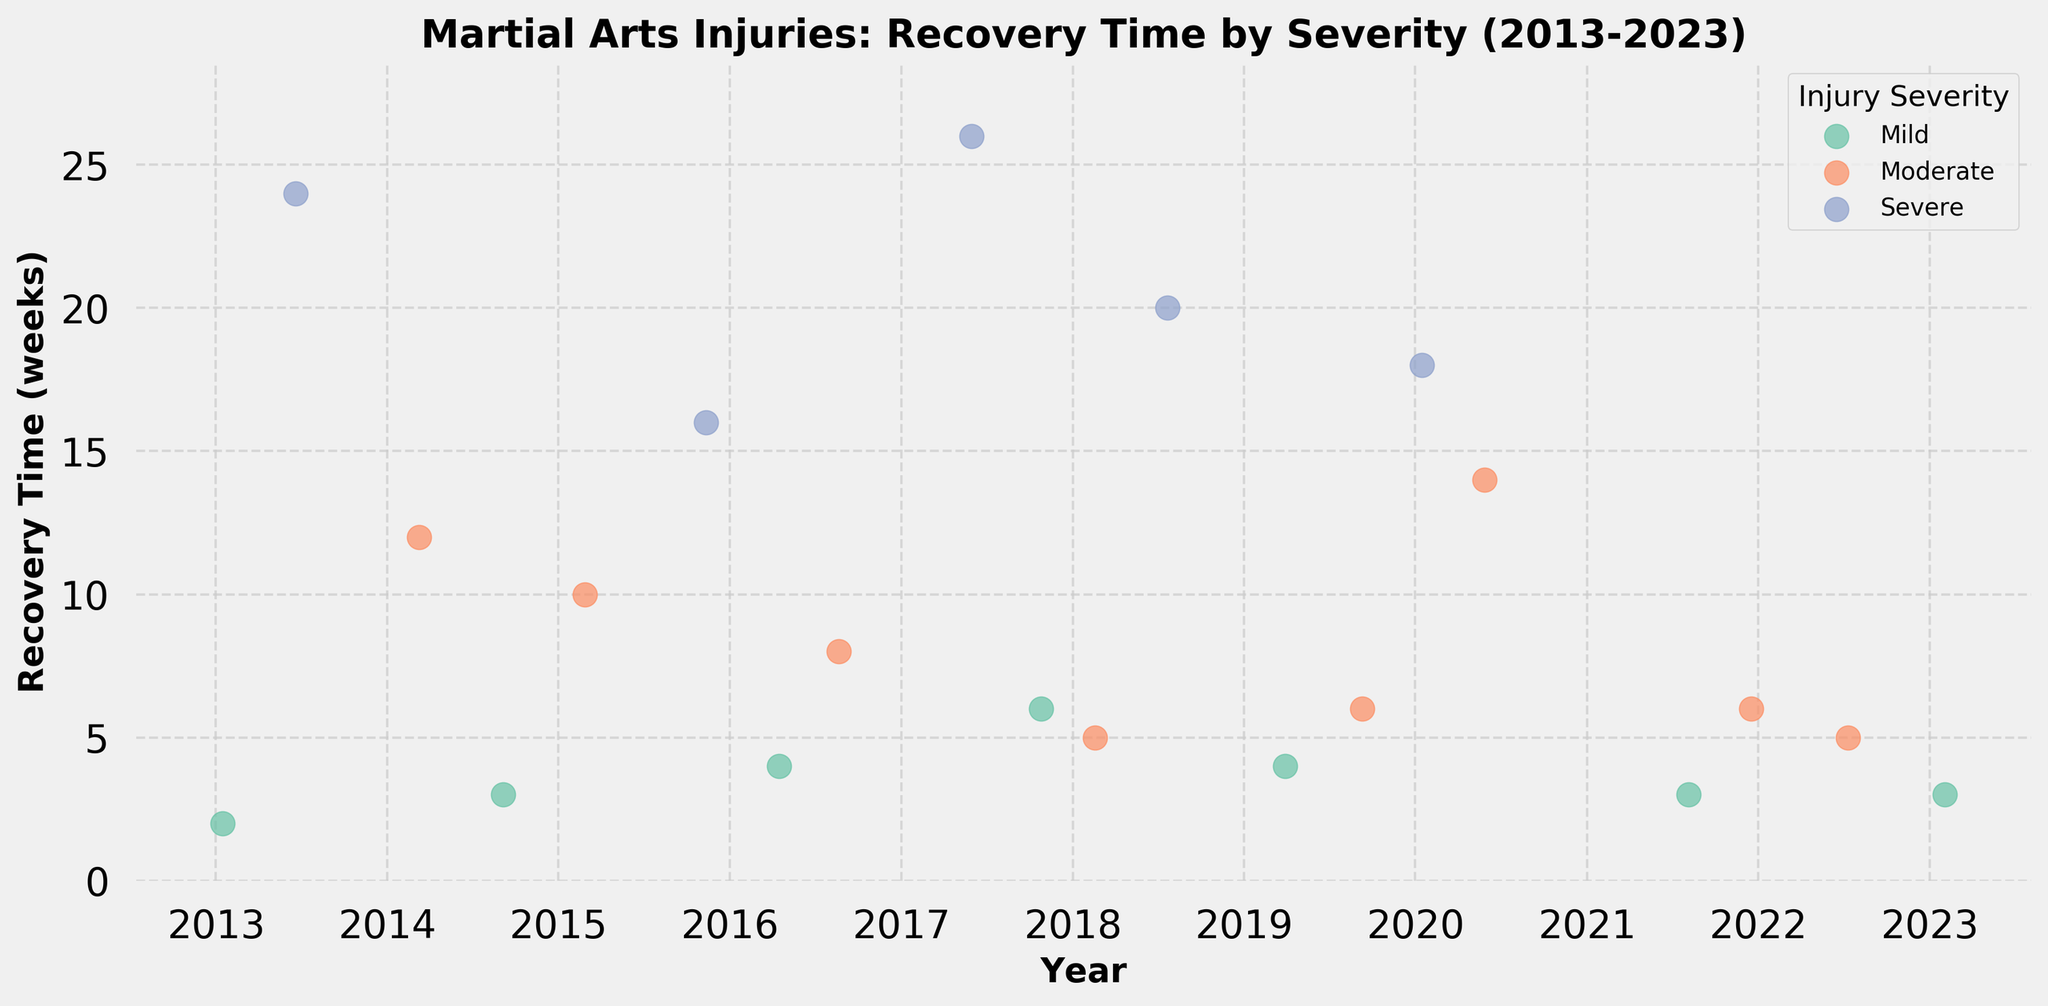What's the title of the figure? The title of a figure is usually displayed prominently at the top. In this case, it clearly states "Martial Arts Injuries: Recovery Time by Severity (2013-2023)".
Answer: Martial Arts Injuries: Recovery Time by Severity (2013-2023) What is the longest recovery time among severe injuries? To find this, look at the dots labeled "Severe" and identify the highest "Recovery Time (weeks)" along the y-axis. The highest point for severe injuries is 26 weeks.
Answer: 26 weeks How many severe injuries are shown in the figure? Count the number of dots represented by the color assigned to "Severe" injuries in the legend. There are four such dots.
Answer: Four Which year had the most injuries? To determine the year with the most injuries, observe the distribution of dots across different years on the x-axis. The year 2015 has the highest concentration of dots.
Answer: 2015 What's the range of recovery times for mild injuries? Look at the dots labeled "Mild" and note the minimum and maximum "Recovery Time (weeks)" values on the y-axis. The range is from 2 to 6 weeks.
Answer: 2 to 6 weeks Which type of injury occurred in February 2019 and how severe was it? By observing the x-axis and finding the dot in February 2019, and referring to the color and legend, we identify the injury "Elbow Hyperextension" with "Mild" severity.
Answer: Elbow Hyperextension, Mild Which injury had a recovery time of 14 weeks and in what year did it happen? Locate the dot at 14 weeks on the y-axis and trace back to its corresponding year on the x-axis. The "Dislocated Knee" had a recovery time of 14 weeks in 2020.
Answer: Dislocated Knee, 2020 Compare the median recovery times of moderate and severe injuries. Which is higher? First, find all recovery times for both moderate and severe injuries. Moderate: 12, 10, 8, 5, 6, 14, 5, 6 (Median = 8). Severe: 24, 16, 26, 20, 18 (Median = 20). The median recovery time for severe injuries is higher.
Answer: Severe (20 weeks) Between 2018 and 2021, which category had more instances of injuries: mild or moderate? Count the dots for both mild and moderate injuries between 2018 and 2021. Mild: 2 (2019 and 2021). Moderate: 4 (2018, 2019, 2020, 2021). Moderate injuries occurred more often.
Answer: Moderate How many injuries in total are recorded in the data set? Count each dot on the figure irrespective of color or size. There are 19 dots in total.
Answer: 19 